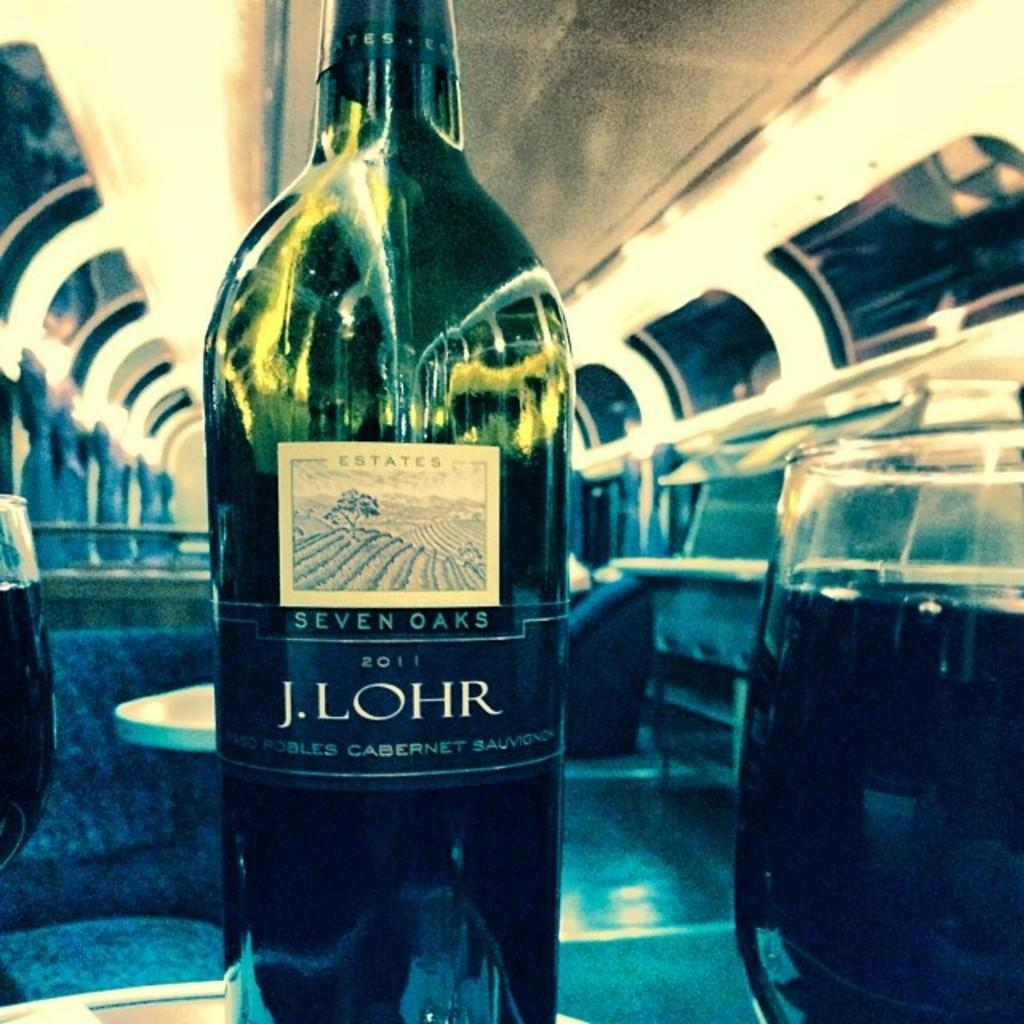<image>
Describe the image concisely. A bottle of J. Lohr sits on a table next to a glass. 